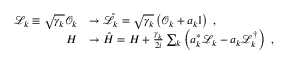Convert formula to latex. <formula><loc_0><loc_0><loc_500><loc_500>\begin{array} { r l } { \mathcal { L } _ { k } \equiv \sqrt { \gamma _ { k } } \mathcal { O } _ { k } } & { \rightarrow \hat { \mathcal { L } } _ { k } = \sqrt { \gamma _ { k } } \left ( \mathcal { O } _ { k } + a _ { k } \mathbb { I } \right ) \, , } \\ { H } & { \rightarrow \hat { H } = H + \frac { \gamma _ { k } } { 2 i } \sum _ { k } \left ( a _ { k } ^ { * } \mathcal { L } _ { k } - a _ { k } \mathcal { L } _ { k } ^ { \dagger } \right ) \, , } \end{array}</formula> 